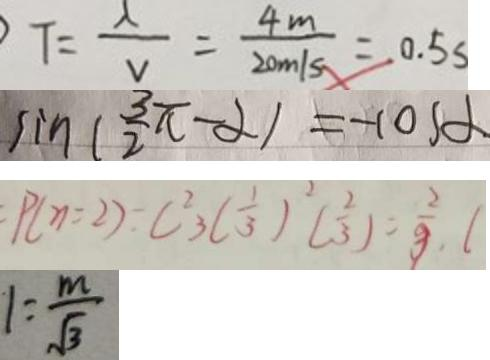<formula> <loc_0><loc_0><loc_500><loc_500>F = \frac { \lambda } { v } = \frac { 4 m } { 2 0 m / s } = 0 . 5 s 
 \sin ( \frac { 3 \pi } { 2 } - \alpha ) = - \cos \alpha 
 P ( \eta = 2 ) = C ^ { 2 } _ { 3 } ( \frac { 1 } { 3 } ) ^ { 2 } ( \frac { 2 } { 3 } ) = \frac { 2 } { 9 } , ( 
 1 = \frac { m } { \sqrt { 3 } }</formula> 